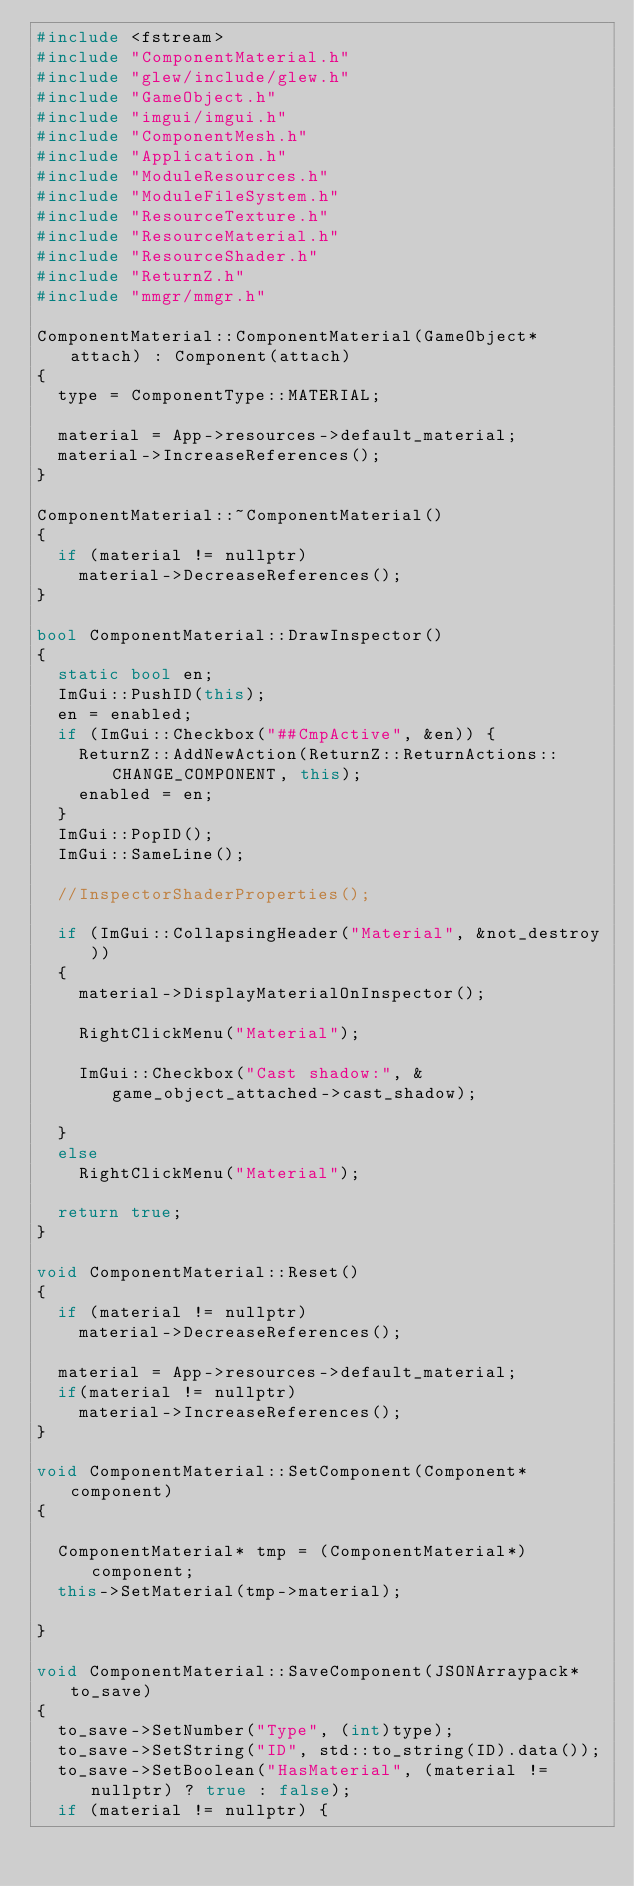Convert code to text. <code><loc_0><loc_0><loc_500><loc_500><_C++_>#include <fstream>
#include "ComponentMaterial.h"
#include "glew/include/glew.h"
#include "GameObject.h"
#include "imgui/imgui.h"
#include "ComponentMesh.h"
#include "Application.h"
#include "ModuleResources.h"
#include "ModuleFileSystem.h"
#include "ResourceTexture.h"
#include "ResourceMaterial.h"
#include "ResourceShader.h"
#include "ReturnZ.h"
#include "mmgr/mmgr.h"

ComponentMaterial::ComponentMaterial(GameObject* attach) : Component(attach)
{
	type = ComponentType::MATERIAL;

	material = App->resources->default_material;
	material->IncreaseReferences();
}

ComponentMaterial::~ComponentMaterial()
{
	if (material != nullptr)
		material->DecreaseReferences();
}

bool ComponentMaterial::DrawInspector()
{
	static bool en;
	ImGui::PushID(this);
	en = enabled;
	if (ImGui::Checkbox("##CmpActive", &en)) {
		ReturnZ::AddNewAction(ReturnZ::ReturnActions::CHANGE_COMPONENT, this);
		enabled = en;
	}
	ImGui::PopID();
	ImGui::SameLine();

	//InspectorShaderProperties();

	if (ImGui::CollapsingHeader("Material", &not_destroy))
	{
		material->DisplayMaterialOnInspector();
		
		RightClickMenu("Material");

		ImGui::Checkbox("Cast shadow:", &game_object_attached->cast_shadow);

	}
	else
		RightClickMenu("Material");

	return true;
}

void ComponentMaterial::Reset()
{
	if (material != nullptr)
		material->DecreaseReferences();
	
	material = App->resources->default_material;
	if(material != nullptr)
		material->IncreaseReferences();
}

void ComponentMaterial::SetComponent(Component* component)
{
	
	ComponentMaterial* tmp = (ComponentMaterial*)component;
	this->SetMaterial(tmp->material);

}

void ComponentMaterial::SaveComponent(JSONArraypack* to_save)
{
	to_save->SetNumber("Type", (int)type);
	to_save->SetString("ID", std::to_string(ID).data());
	to_save->SetBoolean("HasMaterial", (material != nullptr) ? true : false);
	if (material != nullptr) {</code> 